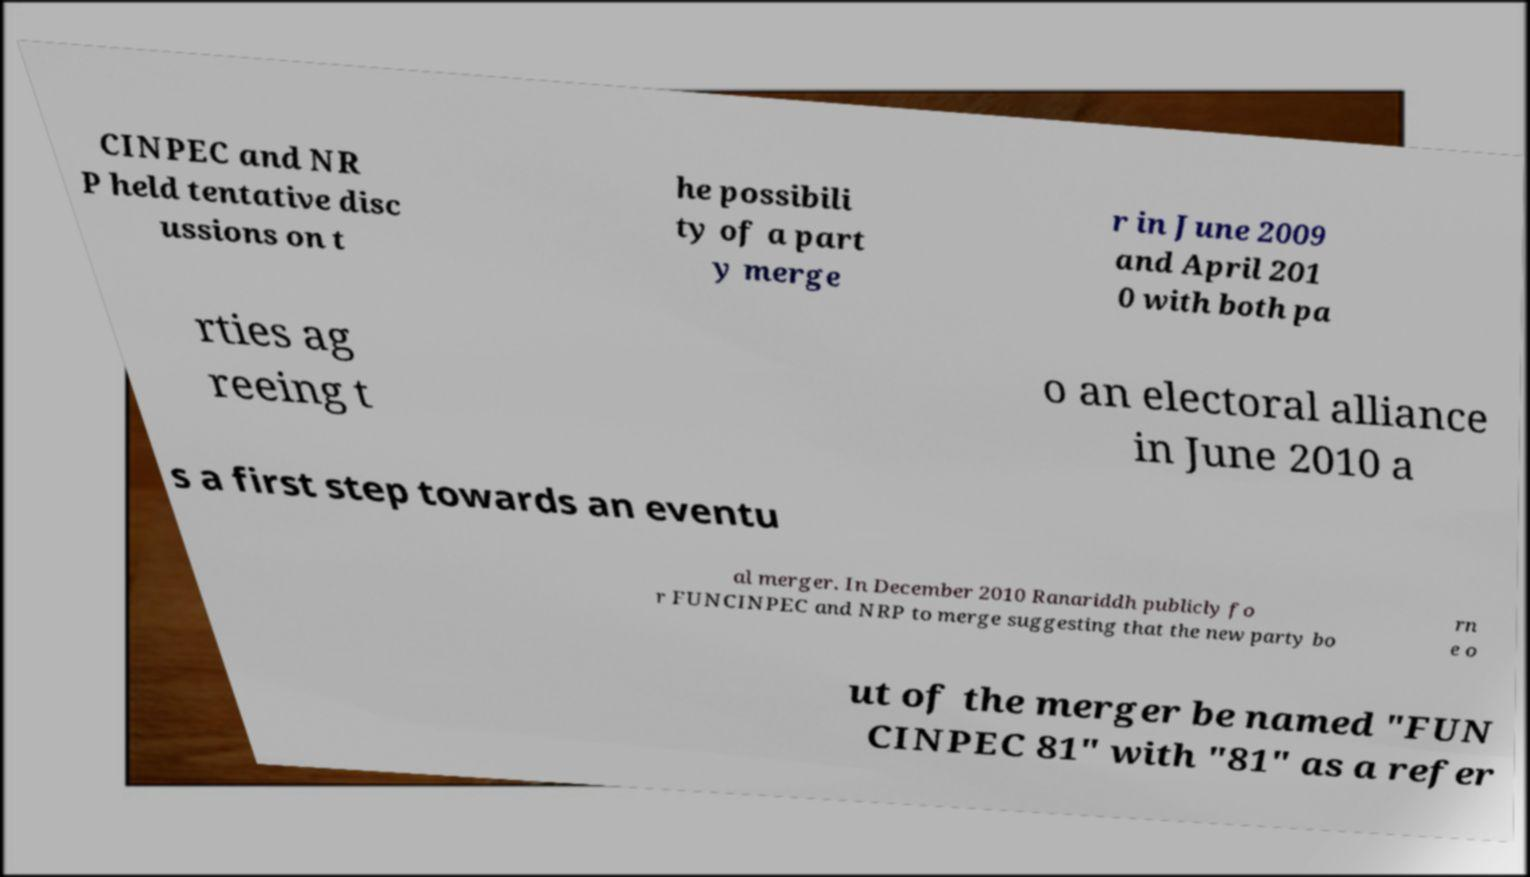For documentation purposes, I need the text within this image transcribed. Could you provide that? CINPEC and NR P held tentative disc ussions on t he possibili ty of a part y merge r in June 2009 and April 201 0 with both pa rties ag reeing t o an electoral alliance in June 2010 a s a first step towards an eventu al merger. In December 2010 Ranariddh publicly fo r FUNCINPEC and NRP to merge suggesting that the new party bo rn e o ut of the merger be named "FUN CINPEC 81" with "81" as a refer 